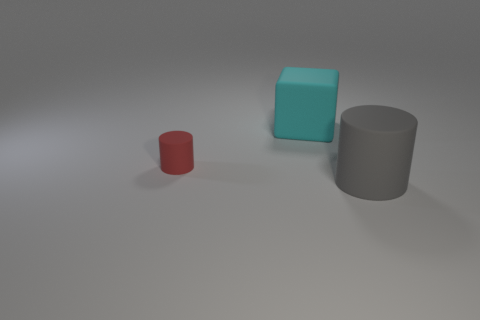Is there anything else that is the same size as the red matte cylinder?
Your answer should be compact. No. There is a cylinder right of the cyan block; is it the same size as the big cube?
Keep it short and to the point. Yes. What is the shape of the big cyan matte object?
Ensure brevity in your answer.  Cube. What number of small things are the same shape as the large gray object?
Your answer should be compact. 1. What number of matte objects are to the left of the gray matte thing and in front of the block?
Keep it short and to the point. 1. What color is the small matte thing?
Give a very brief answer. Red. Is there a big green block made of the same material as the gray cylinder?
Offer a terse response. No. There is a large rubber thing to the right of the big matte object that is behind the tiny red rubber object; is there a tiny matte thing in front of it?
Offer a very short reply. No. There is a big cyan cube; are there any cyan objects to the right of it?
Provide a short and direct response. No. Are there any large metallic blocks of the same color as the big rubber block?
Your answer should be very brief. No. 